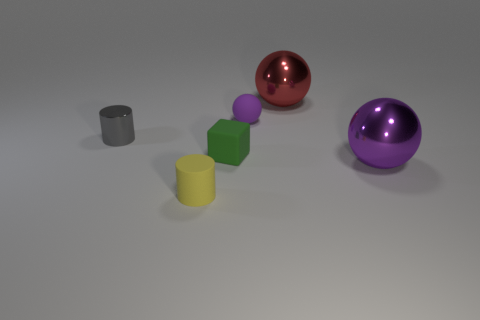There is a small thing behind the metal thing that is to the left of the yellow thing that is in front of the green object; what is its color?
Your answer should be very brief. Purple. There is a purple thing that is on the right side of the red shiny ball; is its shape the same as the tiny purple matte object?
Provide a short and direct response. Yes. What number of small purple metallic cubes are there?
Offer a very short reply. 0. How many things are the same size as the green rubber block?
Give a very brief answer. 3. What is the yellow cylinder made of?
Your answer should be compact. Rubber. Does the tiny rubber sphere have the same color as the thing on the right side of the red metal sphere?
Your answer should be very brief. Yes. There is a object that is both right of the block and in front of the green thing; how big is it?
Offer a very short reply. Large. What is the shape of the tiny purple thing that is made of the same material as the small yellow cylinder?
Offer a very short reply. Sphere. Do the gray object and the purple thing on the left side of the red thing have the same material?
Provide a succinct answer. No. Are there any tiny purple balls in front of the purple sphere in front of the small green object?
Ensure brevity in your answer.  No. 